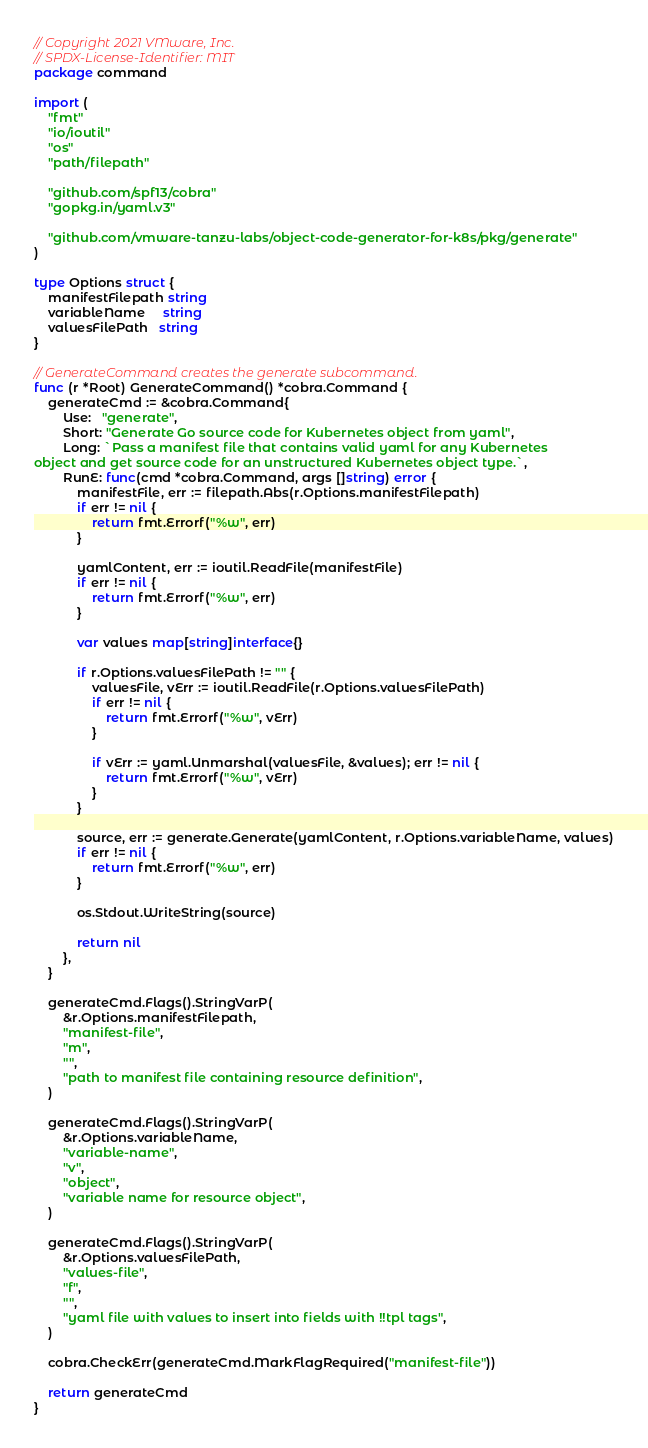Convert code to text. <code><loc_0><loc_0><loc_500><loc_500><_Go_>// Copyright 2021 VMware, Inc.
// SPDX-License-Identifier: MIT
package command

import (
	"fmt"
	"io/ioutil"
	"os"
	"path/filepath"

	"github.com/spf13/cobra"
	"gopkg.in/yaml.v3"

	"github.com/vmware-tanzu-labs/object-code-generator-for-k8s/pkg/generate"
)

type Options struct {
	manifestFilepath string
	variableName     string
	valuesFilePath   string
}

// GenerateCommand creates the generate subcommand.
func (r *Root) GenerateCommand() *cobra.Command {
	generateCmd := &cobra.Command{
		Use:   "generate",
		Short: "Generate Go source code for Kubernetes object from yaml",
		Long: `Pass a manifest file that contains valid yaml for any Kubernetes
object and get source code for an unstructured Kubernetes object type.`,
		RunE: func(cmd *cobra.Command, args []string) error {
			manifestFile, err := filepath.Abs(r.Options.manifestFilepath)
			if err != nil {
				return fmt.Errorf("%w", err)
			}

			yamlContent, err := ioutil.ReadFile(manifestFile)
			if err != nil {
				return fmt.Errorf("%w", err)
			}

			var values map[string]interface{}

			if r.Options.valuesFilePath != "" {
				valuesFile, vErr := ioutil.ReadFile(r.Options.valuesFilePath)
				if err != nil {
					return fmt.Errorf("%w", vErr)
				}

				if vErr := yaml.Unmarshal(valuesFile, &values); err != nil {
					return fmt.Errorf("%w", vErr)
				}
			}

			source, err := generate.Generate(yamlContent, r.Options.variableName, values)
			if err != nil {
				return fmt.Errorf("%w", err)
			}

			os.Stdout.WriteString(source)

			return nil
		},
	}

	generateCmd.Flags().StringVarP(
		&r.Options.manifestFilepath,
		"manifest-file",
		"m",
		"",
		"path to manifest file containing resource definition",
	)

	generateCmd.Flags().StringVarP(
		&r.Options.variableName,
		"variable-name",
		"v",
		"object",
		"variable name for resource object",
	)

	generateCmd.Flags().StringVarP(
		&r.Options.valuesFilePath,
		"values-file",
		"f",
		"",
		"yaml file with values to insert into fields with !!tpl tags",
	)

	cobra.CheckErr(generateCmd.MarkFlagRequired("manifest-file"))

	return generateCmd
}
</code> 